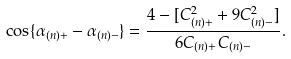Convert formula to latex. <formula><loc_0><loc_0><loc_500><loc_500>\cos \{ \alpha _ { ( n ) + } - \alpha _ { ( n ) - } \} = \frac { 4 - [ C _ { ( n ) + } ^ { 2 } + 9 C _ { ( n ) - } ^ { 2 } ] } { 6 C _ { ( n ) + } C _ { ( n ) - } } .</formula> 